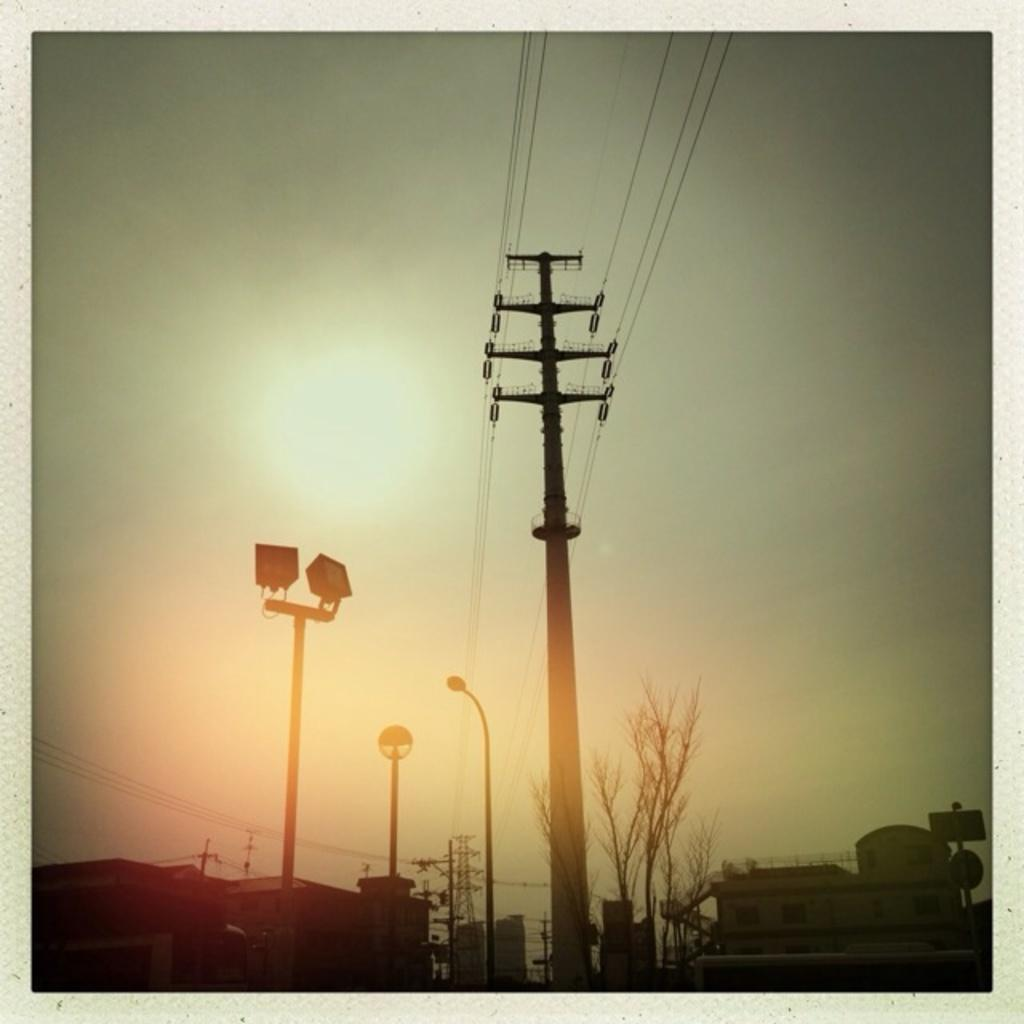What can be seen at the bottom of the picture? There are buildings, trees, current poles, cables, and a street light at the bottom of the picture. What type of vegetation is present at the bottom of the picture? There are trees at the bottom of the picture. What is the purpose of the current poles at the bottom of the picture? The current poles are likely used to support cables, which may be for electricity or communication. What is visible at the top of the picture? The sky is visible at the top of the picture. What is the weather like in the image? The sky is sunny, suggesting a clear and bright day. What type of animal can be seen crossing the boundary in the image? There is no animal crossing any boundary in the image; the focus is on the buildings, trees, current poles, cables, and street light at the bottom of the picture, as well as the sunny sky at the top. 